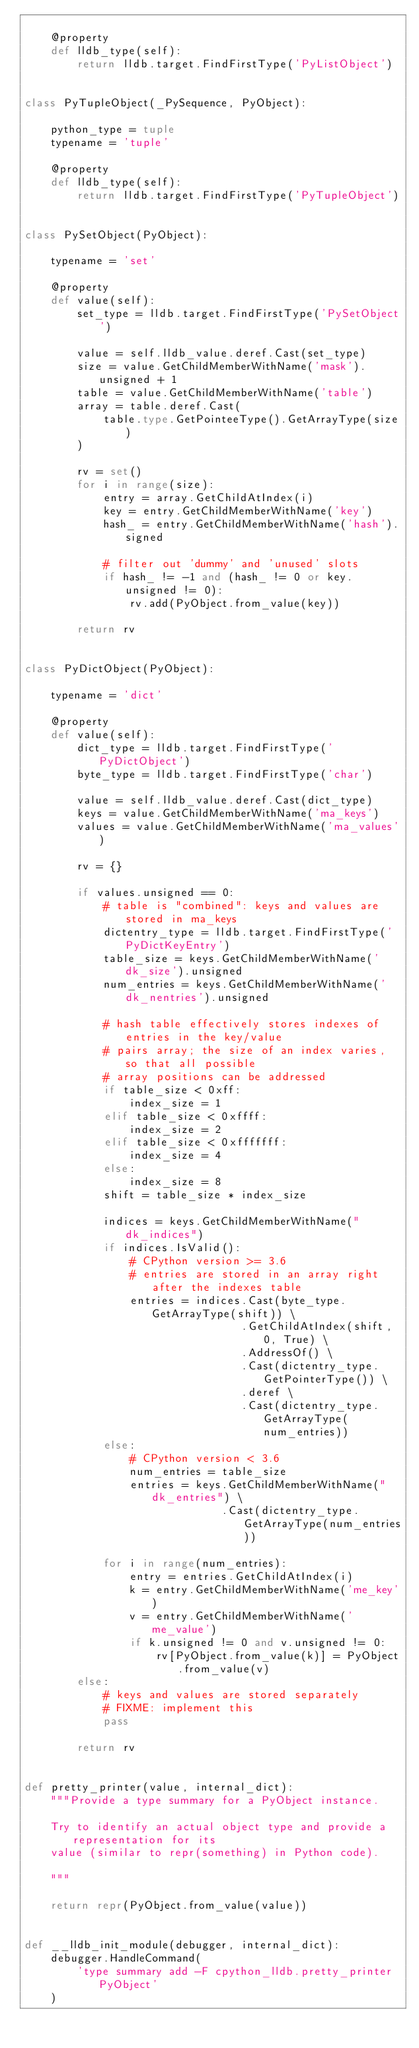<code> <loc_0><loc_0><loc_500><loc_500><_Python_>
    @property
    def lldb_type(self):
        return lldb.target.FindFirstType('PyListObject')


class PyTupleObject(_PySequence, PyObject):

    python_type = tuple
    typename = 'tuple'

    @property
    def lldb_type(self):
        return lldb.target.FindFirstType('PyTupleObject')


class PySetObject(PyObject):

    typename = 'set'

    @property
    def value(self):
        set_type = lldb.target.FindFirstType('PySetObject')

        value = self.lldb_value.deref.Cast(set_type)
        size = value.GetChildMemberWithName('mask').unsigned + 1
        table = value.GetChildMemberWithName('table')
        array = table.deref.Cast(
            table.type.GetPointeeType().GetArrayType(size)
        )

        rv = set()
        for i in range(size):
            entry = array.GetChildAtIndex(i)
            key = entry.GetChildMemberWithName('key')
            hash_ = entry.GetChildMemberWithName('hash').signed

            # filter out 'dummy' and 'unused' slots
            if hash_ != -1 and (hash_ != 0 or key.unsigned != 0):
                rv.add(PyObject.from_value(key))

        return rv


class PyDictObject(PyObject):

    typename = 'dict'

    @property
    def value(self):
        dict_type = lldb.target.FindFirstType('PyDictObject')
        byte_type = lldb.target.FindFirstType('char')

        value = self.lldb_value.deref.Cast(dict_type)
        keys = value.GetChildMemberWithName('ma_keys')
        values = value.GetChildMemberWithName('ma_values')

        rv = {}

        if values.unsigned == 0:
            # table is "combined": keys and values are stored in ma_keys
            dictentry_type = lldb.target.FindFirstType('PyDictKeyEntry')
            table_size = keys.GetChildMemberWithName('dk_size').unsigned
            num_entries = keys.GetChildMemberWithName('dk_nentries').unsigned

            # hash table effectively stores indexes of entries in the key/value
            # pairs array; the size of an index varies, so that all possible
            # array positions can be addressed
            if table_size < 0xff:
                index_size = 1
            elif table_size < 0xffff:
                index_size = 2
            elif table_size < 0xfffffff:
                index_size = 4
            else:
                index_size = 8
            shift = table_size * index_size

            indices = keys.GetChildMemberWithName("dk_indices")
            if indices.IsValid():
                # CPython version >= 3.6
                # entries are stored in an array right after the indexes table
                entries = indices.Cast(byte_type.GetArrayType(shift)) \
                                 .GetChildAtIndex(shift, 0, True) \
                                 .AddressOf() \
                                 .Cast(dictentry_type.GetPointerType()) \
                                 .deref \
                                 .Cast(dictentry_type.GetArrayType(num_entries))
            else:
                # CPython version < 3.6
                num_entries = table_size
                entries = keys.GetChildMemberWithName("dk_entries") \
                              .Cast(dictentry_type.GetArrayType(num_entries))

            for i in range(num_entries):
                entry = entries.GetChildAtIndex(i)
                k = entry.GetChildMemberWithName('me_key')
                v = entry.GetChildMemberWithName('me_value')
                if k.unsigned != 0 and v.unsigned != 0:
                    rv[PyObject.from_value(k)] = PyObject.from_value(v)
        else:
            # keys and values are stored separately
            # FIXME: implement this
            pass

        return rv


def pretty_printer(value, internal_dict):
    """Provide a type summary for a PyObject instance.

    Try to identify an actual object type and provide a representation for its
    value (similar to repr(something) in Python code).

    """

    return repr(PyObject.from_value(value))


def __lldb_init_module(debugger, internal_dict):
    debugger.HandleCommand(
        'type summary add -F cpython_lldb.pretty_printer PyObject'
    )
</code> 